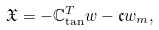<formula> <loc_0><loc_0><loc_500><loc_500>\mathfrak { X } = - \mathbb { C } _ { \tan } ^ { T } w - \mathfrak { c } w _ { m } ,</formula> 